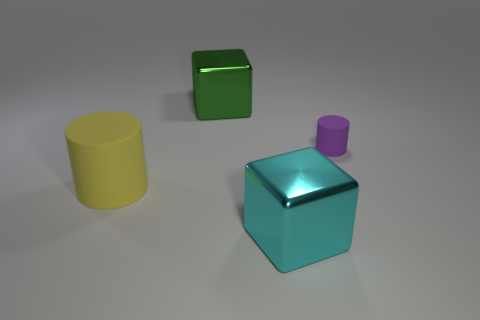Is there any other thing that is the same shape as the small purple object?
Your response must be concise. Yes. There is a small rubber thing that is the same shape as the large matte thing; what color is it?
Your answer should be compact. Purple. What size is the cyan shiny cube?
Keep it short and to the point. Large. Are there fewer large metal blocks to the left of the purple thing than big cyan metallic things?
Your answer should be compact. No. Does the small purple cylinder have the same material as the block left of the cyan metal object?
Offer a terse response. No. There is a block that is left of the large metallic thing in front of the tiny purple matte cylinder; are there any big yellow cylinders that are on the right side of it?
Offer a terse response. No. Is there anything else that has the same size as the yellow rubber cylinder?
Your answer should be very brief. Yes. There is a tiny thing that is the same material as the large yellow thing; what color is it?
Provide a short and direct response. Purple. There is a thing that is both behind the big matte cylinder and on the left side of the cyan object; how big is it?
Ensure brevity in your answer.  Large. Is the number of metallic cubes on the right side of the big cyan metal thing less than the number of purple objects that are on the left side of the big yellow cylinder?
Ensure brevity in your answer.  No. 